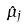<formula> <loc_0><loc_0><loc_500><loc_500>\hat { \mu } _ { j }</formula> 